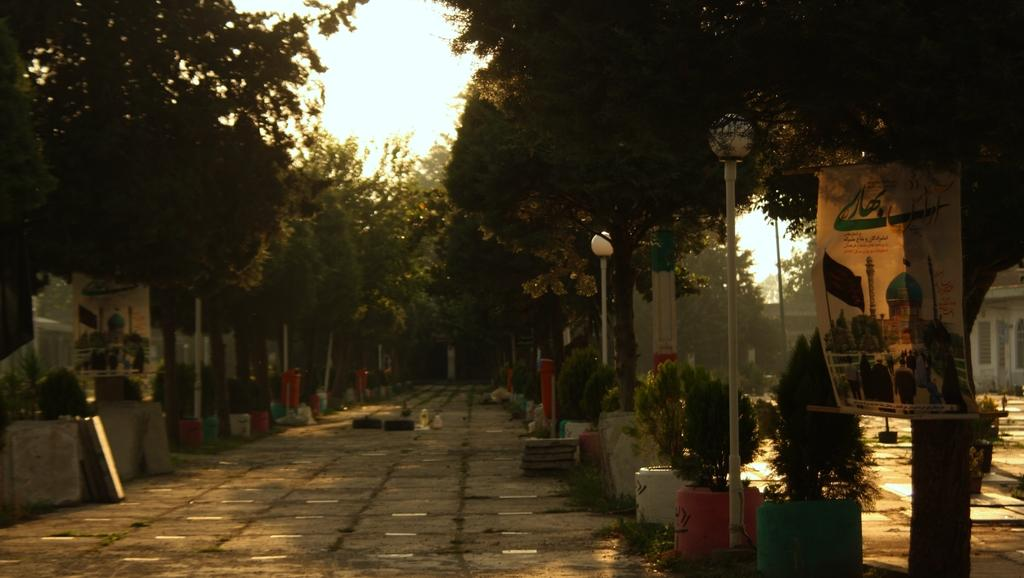What type of vegetation can be seen on both sides of the image? There are trees on either side of the image. What is attached to one of the trees in the image? There is a banner on a tree on the right side of the image. What is visible at the top of the image? The sky is visible at the top of the image. How many girls are combing their hair in the image? There are no girls or combs present in the image. 